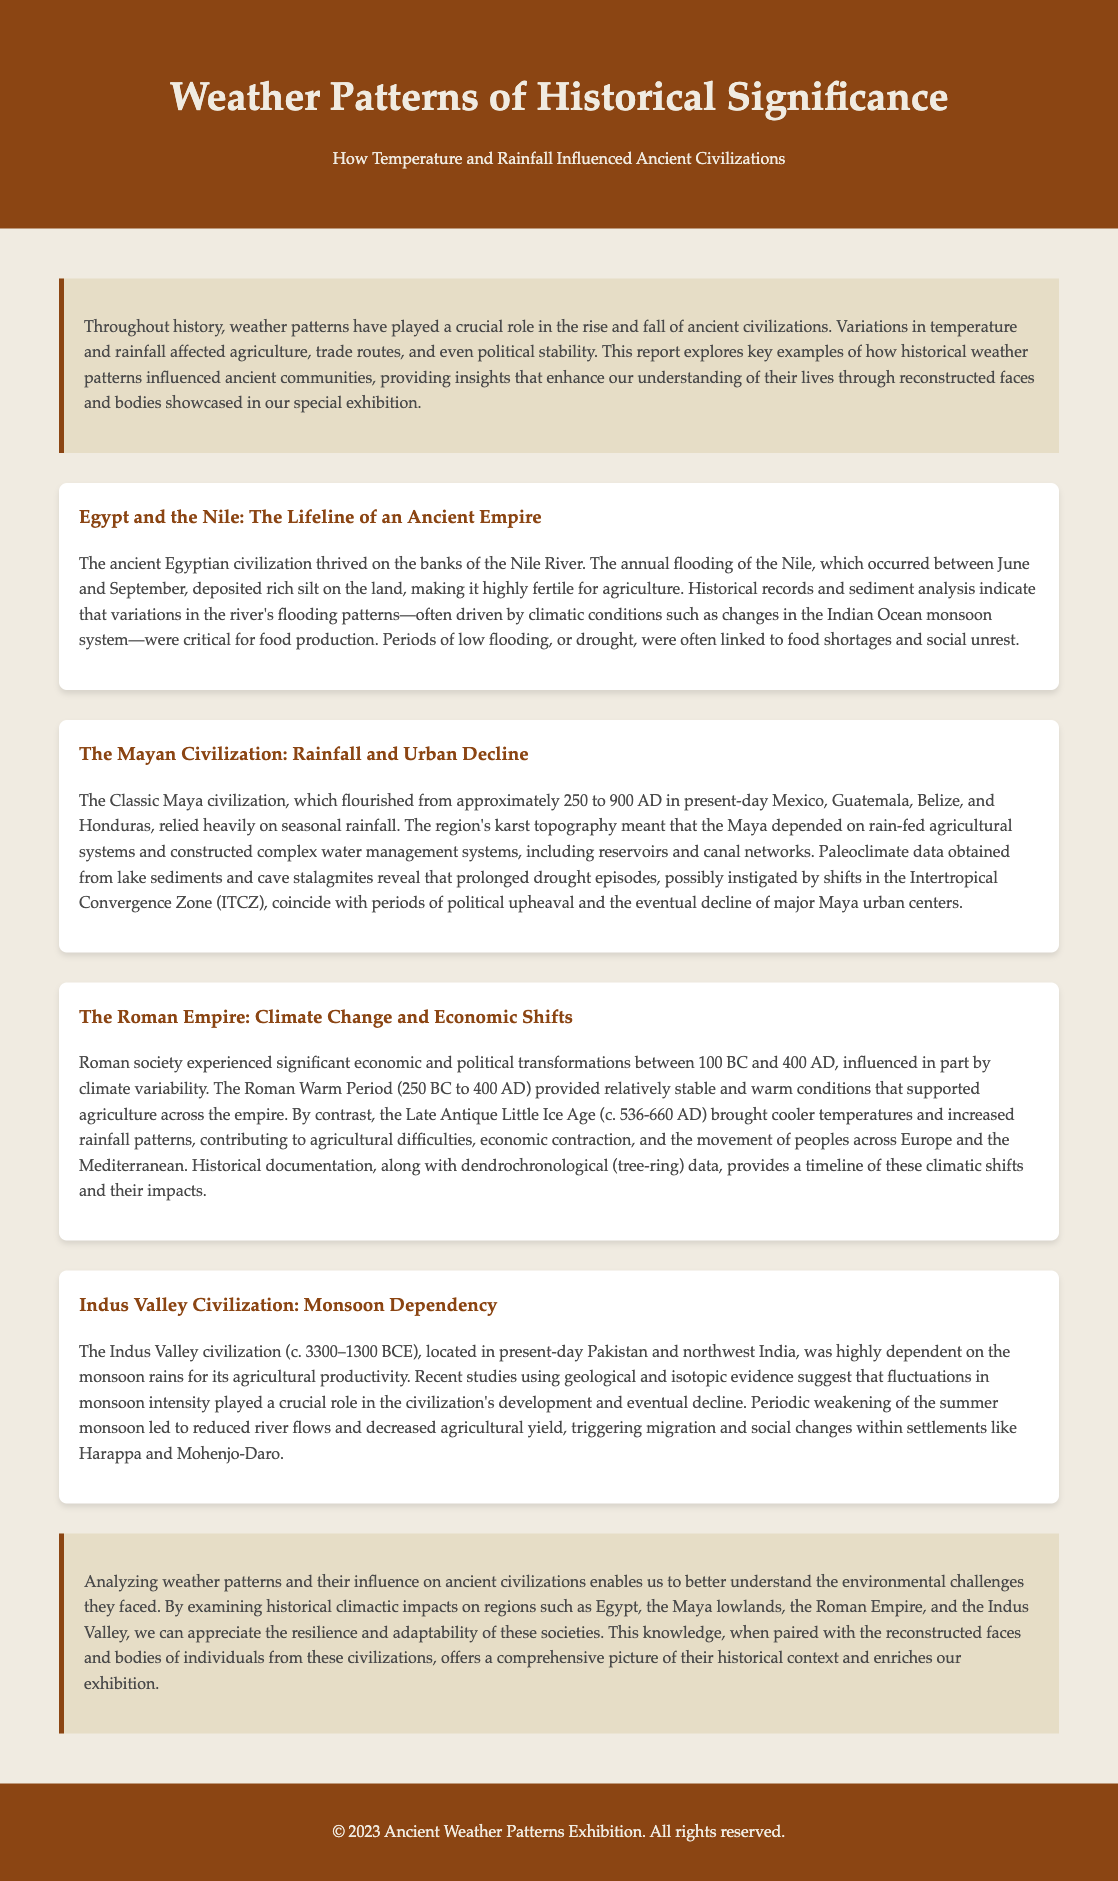What civilization thrived on the banks of the Nile River? The document states that the ancient Egyptian civilization thrived on the banks of the Nile River.
Answer: Egyptian civilization What climatic condition was critical for the Mayan civilization's agriculture? The document mentions that the Classic Maya civilization relied heavily on seasonal rainfall for their agriculture.
Answer: Seasonal rainfall During which period did the Roman Warm Period occur? Historical documentation in the report indicates that the Roman Warm Period occurred between 250 BC and 400 AD.
Answer: 250 BC to 400 AD What was a contributing factor to the decline of the Indus Valley civilization? The document states that periodic weakening of the summer monsoon led to reduced river flows and decreased agricultural yield, triggering migration.
Answer: Weakening of the summer monsoon What event is linked to changes in the Indian Ocean monsoon system? The report indicates that variations in the Nile's flooding patterns were often driven by climatic conditions such as changes in the Indian Ocean monsoon system.
Answer: Nile's flooding patterns Which ancient civilization constructed complex water management systems? The document specifies that the Mayan civilization constructed complex water management systems, including reservoirs and canal networks.
Answer: Mayan civilization What evidence suggests the Roman Empire faced agricultural difficulties? The document provides dendrochronological (tree-ring) data and historical documentation as evidence of climate variability impacting agriculture.
Answer: Dendrochronological data Which two civilizations experienced social unrest due to drought episodes? The report describes that both the ancient Egyptian civilization and the Maya civilization faced social unrest linked to droughts.
Answer: Egyptian and Maya civilizations What type of climatic shifts does dendrochronological data provide insights into? Dendrochronological data in the document provides a timeline of climatic shifts that influenced the Roman Empire.
Answer: Climate shifts in the Roman Empire 